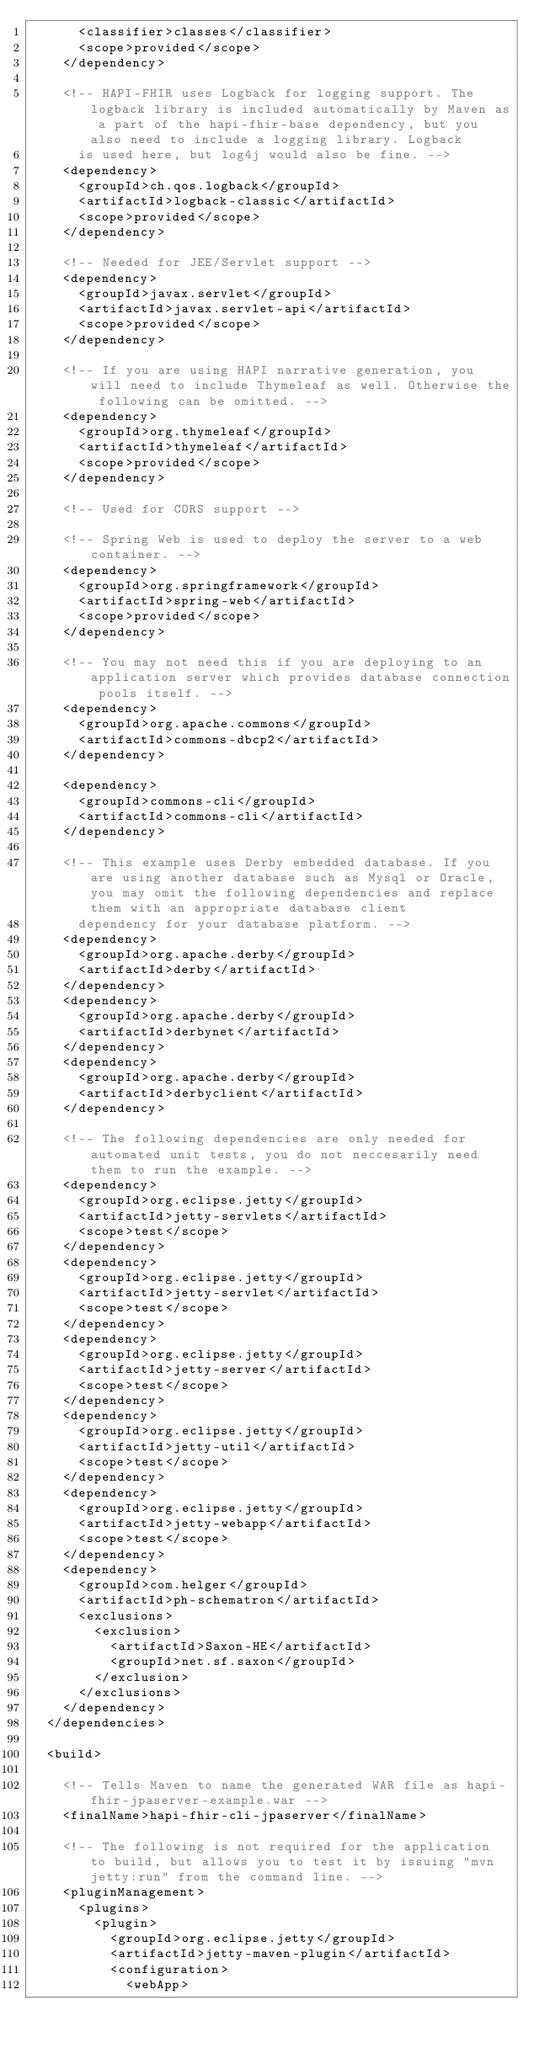<code> <loc_0><loc_0><loc_500><loc_500><_XML_>			<classifier>classes</classifier>
			<scope>provided</scope>
		</dependency>

		<!-- HAPI-FHIR uses Logback for logging support. The logback library is included automatically by Maven as a part of the hapi-fhir-base dependency, but you also need to include a logging library. Logback 
			is used here, but log4j would also be fine. -->
		<dependency>
			<groupId>ch.qos.logback</groupId>
			<artifactId>logback-classic</artifactId>
			<scope>provided</scope>
		</dependency>

		<!-- Needed for JEE/Servlet support -->
		<dependency>
			<groupId>javax.servlet</groupId>
			<artifactId>javax.servlet-api</artifactId>
			<scope>provided</scope>
		</dependency>

		<!-- If you are using HAPI narrative generation, you will need to include Thymeleaf as well. Otherwise the following can be omitted. -->
		<dependency>
			<groupId>org.thymeleaf</groupId>
			<artifactId>thymeleaf</artifactId>
			<scope>provided</scope>
		</dependency>

		<!-- Used for CORS support -->

		<!-- Spring Web is used to deploy the server to a web container. -->
		<dependency>
			<groupId>org.springframework</groupId>
			<artifactId>spring-web</artifactId>
			<scope>provided</scope>
		</dependency>

		<!-- You may not need this if you are deploying to an application server which provides database connection pools itself. -->
		<dependency>
			<groupId>org.apache.commons</groupId>
			<artifactId>commons-dbcp2</artifactId>
		</dependency>

		<dependency>
			<groupId>commons-cli</groupId>
			<artifactId>commons-cli</artifactId>
		</dependency>

		<!-- This example uses Derby embedded database. If you are using another database such as Mysql or Oracle, you may omit the following dependencies and replace them with an appropriate database client 
			dependency for your database platform. -->
		<dependency>
			<groupId>org.apache.derby</groupId>
			<artifactId>derby</artifactId>
		</dependency>
		<dependency>
			<groupId>org.apache.derby</groupId>
			<artifactId>derbynet</artifactId>
		</dependency>
		<dependency>
			<groupId>org.apache.derby</groupId>
			<artifactId>derbyclient</artifactId>
		</dependency>

		<!-- The following dependencies are only needed for automated unit tests, you do not neccesarily need them to run the example. -->
		<dependency>
			<groupId>org.eclipse.jetty</groupId>
			<artifactId>jetty-servlets</artifactId>
			<scope>test</scope>
		</dependency>
		<dependency>
			<groupId>org.eclipse.jetty</groupId>
			<artifactId>jetty-servlet</artifactId>
			<scope>test</scope>
		</dependency>
		<dependency>
			<groupId>org.eclipse.jetty</groupId>
			<artifactId>jetty-server</artifactId>
			<scope>test</scope>
		</dependency>
		<dependency>
			<groupId>org.eclipse.jetty</groupId>
			<artifactId>jetty-util</artifactId>
			<scope>test</scope>
		</dependency>
		<dependency>
			<groupId>org.eclipse.jetty</groupId>
			<artifactId>jetty-webapp</artifactId>
			<scope>test</scope>
		</dependency>
		<dependency>
			<groupId>com.helger</groupId>
			<artifactId>ph-schematron</artifactId>
			<exclusions>
				<exclusion>
					<artifactId>Saxon-HE</artifactId>
					<groupId>net.sf.saxon</groupId>
				</exclusion>
			</exclusions>
		</dependency>
	</dependencies>

	<build>

		<!-- Tells Maven to name the generated WAR file as hapi-fhir-jpaserver-example.war -->
		<finalName>hapi-fhir-cli-jpaserver</finalName>

		<!-- The following is not required for the application to build, but allows you to test it by issuing "mvn jetty:run" from the command line. -->
		<pluginManagement>
			<plugins>
				<plugin>
					<groupId>org.eclipse.jetty</groupId>
					<artifactId>jetty-maven-plugin</artifactId>
					<configuration>
						<webApp></code> 